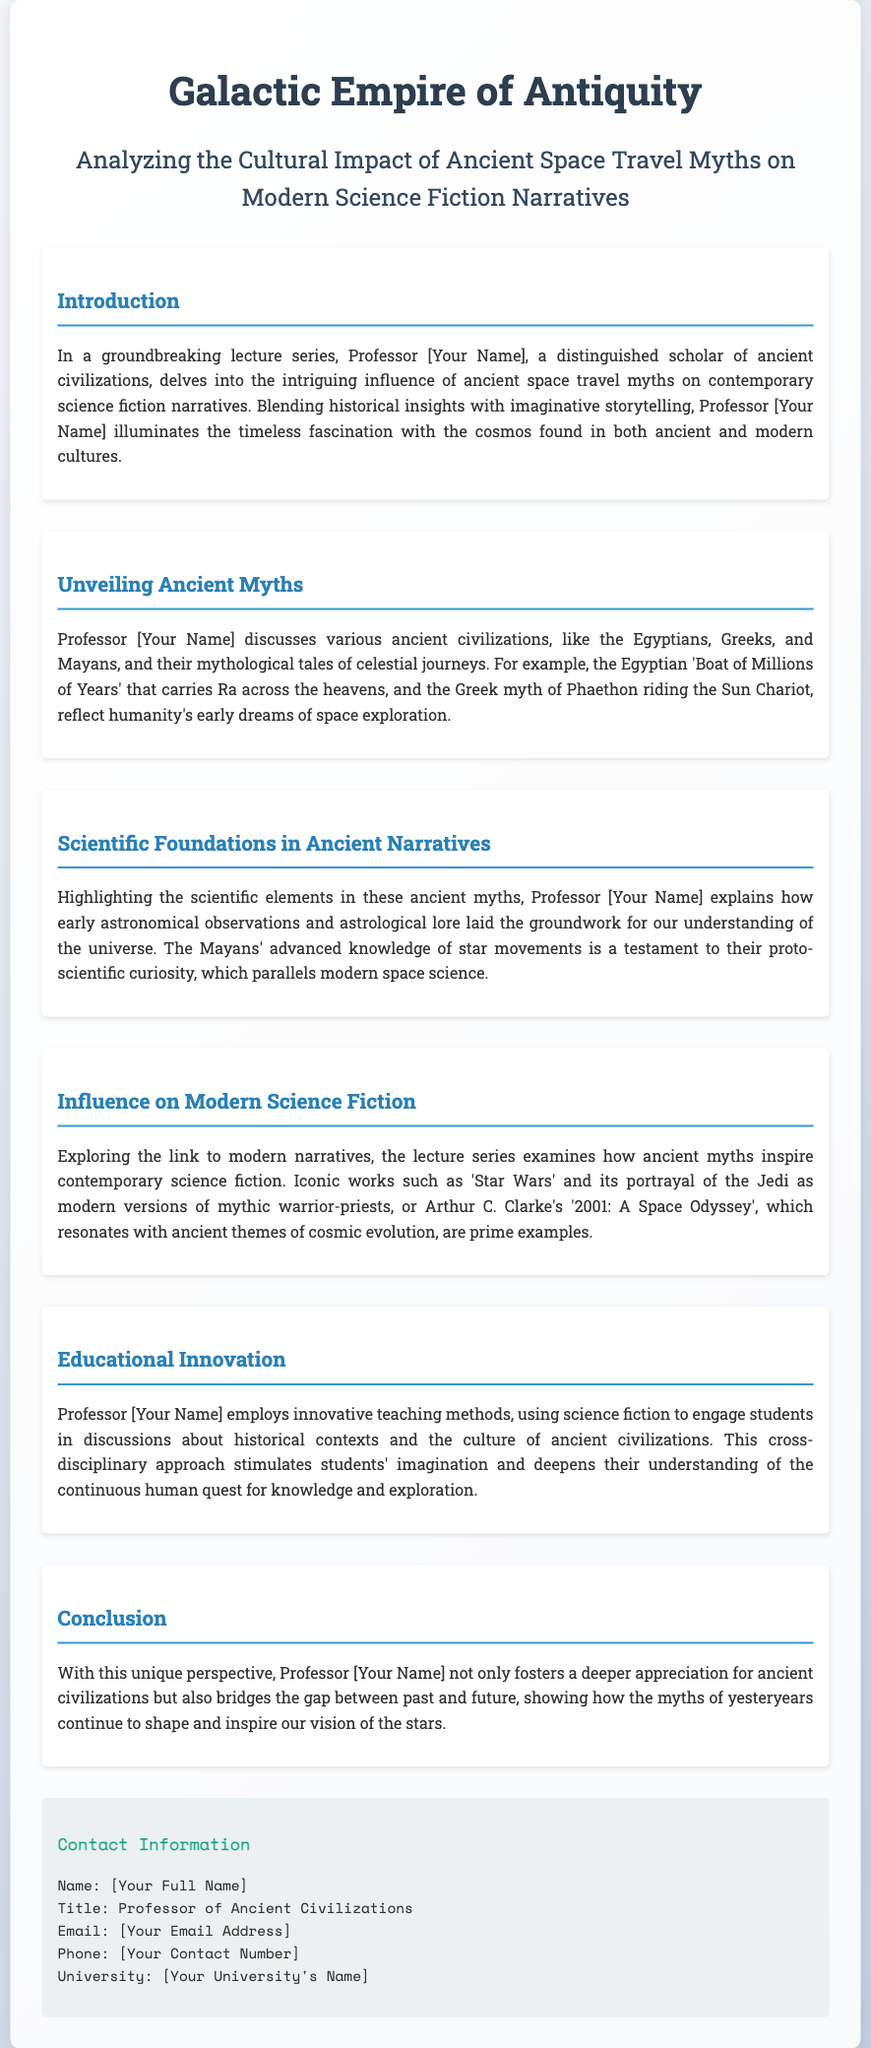What is the title of the lecture series? The title is presented clearly at the top of the document.
Answer: Analyzing the Cultural Impact of Ancient Space Travel Myths on Modern Science Fiction Narratives Who discusses the influence of ancient space travel myths? The document states that Professor [Your Name] is the one discussing these influences.
Answer: Professor [Your Name] Which ancient civilization's myth involves the "Boat of Millions of Years"? This myth is mentioned in the section discussing ancient myths, specifically linked to the Egyptians.
Answer: Egyptians What modern work is associated with cosmic evolution? The document mentions this work in the context of ancient themes in modern narratives.
Answer: 2001: A Space Odyssey What teaching approach does Professor [Your Name] use? The document outlines the method of engaging students through a specific genre.
Answer: Innovative teaching methods What does the conclusion emphasize about ancient civilizations? The conclusion highlights the significance beyond historical interest.
Answer: A deeper appreciation What is the professor's title? This information is explicitly mentioned in the contact section of the document.
Answer: Professor of Ancient Civilizations In which section is the link to modern narratives explored? The document provides a structure where this information is located.
Answer: Influence on Modern Science Fiction 